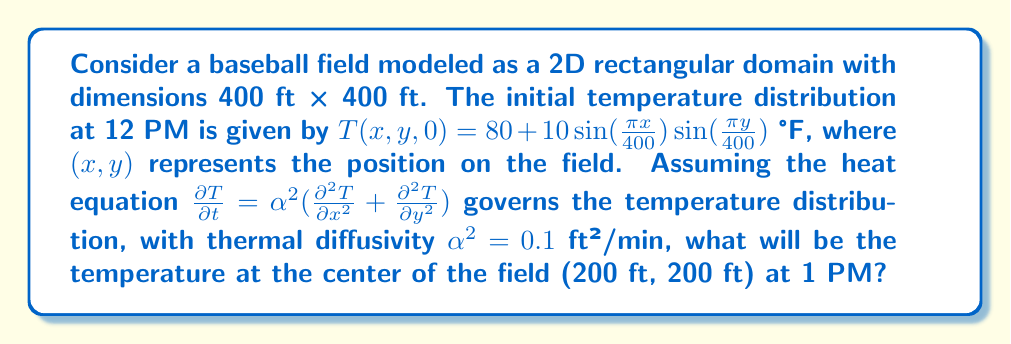Can you answer this question? To solve this problem, we'll follow these steps:

1) The general solution to the 2D heat equation with the given initial condition is:

   $$T(x,y,t) = 80 + 10\sin(\frac{\pi x}{400})\sin(\frac{\pi y}{400})e^{-\alpha^2(\frac{\pi^2}{400^2} + \frac{\pi^2}{400^2})t}$$

2) We need to calculate the temperature at the center (200 ft, 200 ft) after 1 hour (60 minutes). Let's substitute these values:

   $x = 200$, $y = 200$, $t = 60$, $\alpha^2 = 0.1$

3) First, let's calculate the exponential term:

   $$e^{-0.1(\frac{\pi^2}{400^2} + \frac{\pi^2}{400^2}) * 60} = e^{-0.1 * \frac{2\pi^2}{400^2} * 60} \approx 0.9704$$

4) Now, let's calculate the sine terms:

   $$\sin(\frac{\pi * 200}{400})\sin(\frac{\pi * 200}{400}) = \sin(\frac{\pi}{2})\sin(\frac{\pi}{2}) = 1 * 1 = 1$$

5) Putting it all together:

   $$T(200,200,60) = 80 + 10 * 1 * 1 * 0.9704 = 89.704$$

Therefore, the temperature at the center of the field at 1 PM will be approximately 89.704°F.
Answer: 89.704°F 